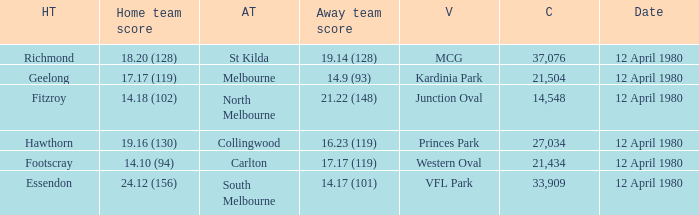Where did Essendon play as the home team? VFL Park. 